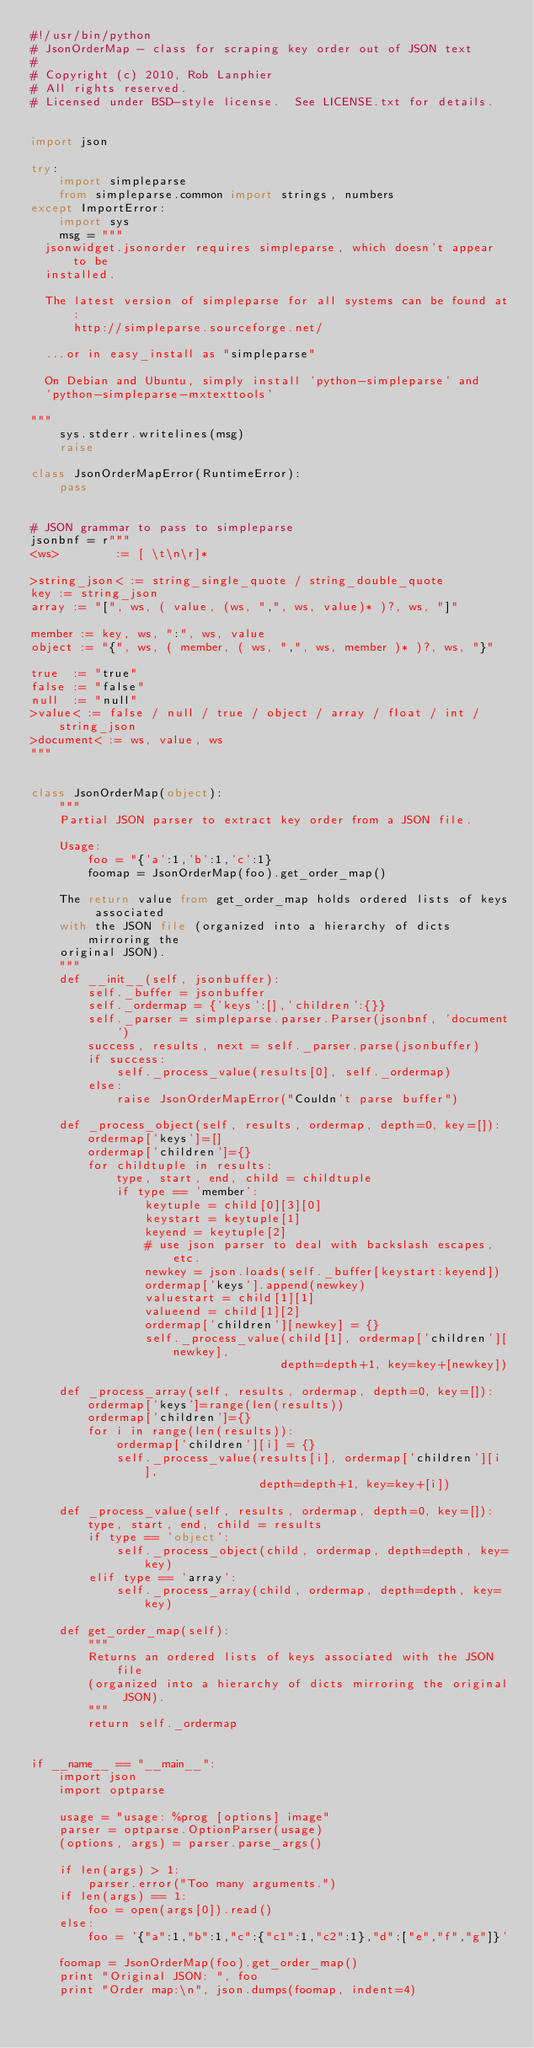<code> <loc_0><loc_0><loc_500><loc_500><_Python_>#!/usr/bin/python
# JsonOrderMap - class for scraping key order out of JSON text
#
# Copyright (c) 2010, Rob Lanphier
# All rights reserved.
# Licensed under BSD-style license.  See LICENSE.txt for details.


import json

try:
    import simpleparse
    from simpleparse.common import strings, numbers
except ImportError:
    import sys
    msg = """
  jsonwidget.jsonorder requires simpleparse, which doesn't appear to be
  installed.  
  
  The latest version of simpleparse for all systems can be found at:
      http://simpleparse.sourceforge.net/

  ...or in easy_install as "simpleparse"

  On Debian and Ubuntu, simply install 'python-simpleparse' and
  'python-simpleparse-mxtexttools'

"""
    sys.stderr.writelines(msg)
    raise

class JsonOrderMapError(RuntimeError):
    pass


# JSON grammar to pass to simpleparse
jsonbnf = r"""
<ws>        := [ \t\n\r]*

>string_json< := string_single_quote / string_double_quote
key := string_json
array := "[", ws, ( value, (ws, ",", ws, value)* )?, ws, "]"

member := key, ws, ":", ws, value 
object := "{", ws, ( member, ( ws, ",", ws, member )* )?, ws, "}"

true  := "true"
false := "false"
null  := "null"
>value< := false / null / true / object / array / float / int / string_json
>document< := ws, value, ws
"""


class JsonOrderMap(object):
    """
    Partial JSON parser to extract key order from a JSON file.
    
    Usage:
        foo = "{'a':1,'b':1,'c':1}
        foomap = JsonOrderMap(foo).get_order_map()
        
    The return value from get_order_map holds ordered lists of keys associated
    with the JSON file (organized into a hierarchy of dicts mirroring the 
    original JSON).
    """
    def __init__(self, jsonbuffer): 
        self._buffer = jsonbuffer
        self._ordermap = {'keys':[],'children':{}}
        self._parser = simpleparse.parser.Parser(jsonbnf, 'document')
        success, results, next = self._parser.parse(jsonbuffer)
        if success:
            self._process_value(results[0], self._ordermap)
        else:
            raise JsonOrderMapError("Couldn't parse buffer")

    def _process_object(self, results, ordermap, depth=0, key=[]):
        ordermap['keys']=[]
        ordermap['children']={}
        for childtuple in results:
            type, start, end, child = childtuple
            if type == 'member':
                keytuple = child[0][3][0]
                keystart = keytuple[1]
                keyend = keytuple[2]
                # use json parser to deal with backslash escapes, etc.
                newkey = json.loads(self._buffer[keystart:keyend])
                ordermap['keys'].append(newkey)
                valuestart = child[1][1]
                valueend = child[1][2]
                ordermap['children'][newkey] = {}
                self._process_value(child[1], ordermap['children'][newkey], 
                                   depth=depth+1, key=key+[newkey])

    def _process_array(self, results, ordermap, depth=0, key=[]):
        ordermap['keys']=range(len(results))
        ordermap['children']={}
        for i in range(len(results)):
            ordermap['children'][i] = {}
            self._process_value(results[i], ordermap['children'][i], 
                                depth=depth+1, key=key+[i])

    def _process_value(self, results, ordermap, depth=0, key=[]):
        type, start, end, child = results
        if type == 'object':
            self._process_object(child, ordermap, depth=depth, key=key)
        elif type == 'array':
            self._process_array(child, ordermap, depth=depth, key=key)

    def get_order_map(self):
        """
        Returns an ordered lists of keys associated with the JSON file 
        (organized into a hierarchy of dicts mirroring the original JSON).
        """
        return self._ordermap


if __name__ == "__main__":
    import json
    import optparse

    usage = "usage: %prog [options] image"
    parser = optparse.OptionParser(usage)
    (options, args) = parser.parse_args()

    if len(args) > 1:
        parser.error("Too many arguments.")
    if len(args) == 1:
        foo = open(args[0]).read()
    else:
        foo = '{"a":1,"b":1,"c":{"c1":1,"c2":1},"d":["e","f","g"]}'

    foomap = JsonOrderMap(foo).get_order_map()
    print "Original JSON: ", foo
    print "Order map:\n", json.dumps(foomap, indent=4)
    

</code> 